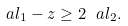<formula> <loc_0><loc_0><loc_500><loc_500>\ a l _ { 1 } - z \geq 2 \ a l _ { 2 } .</formula> 